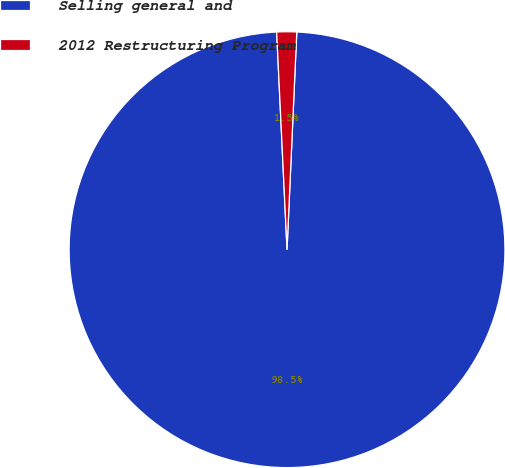Convert chart. <chart><loc_0><loc_0><loc_500><loc_500><pie_chart><fcel>Selling general and<fcel>2012 Restructuring Program<nl><fcel>98.53%<fcel>1.47%<nl></chart> 